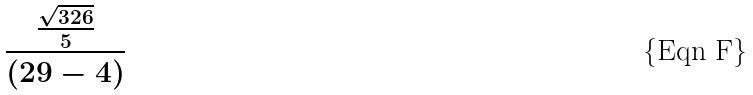<formula> <loc_0><loc_0><loc_500><loc_500>\frac { \frac { \sqrt { 3 2 6 } } { 5 } } { ( 2 9 - 4 ) }</formula> 